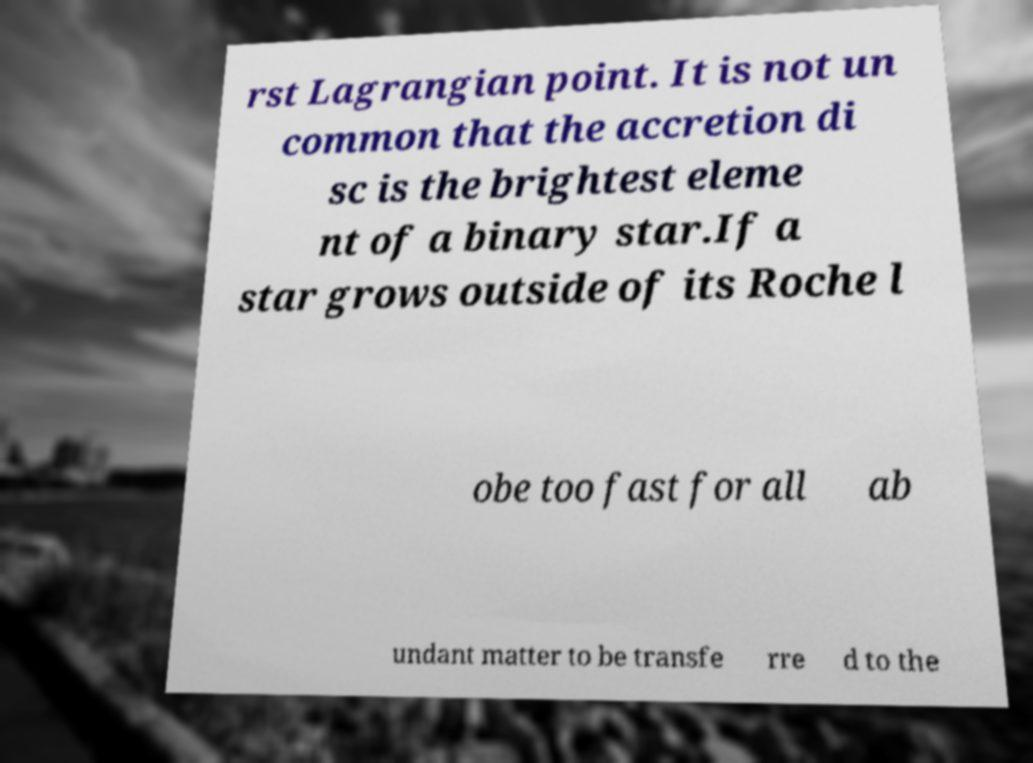Can you read and provide the text displayed in the image?This photo seems to have some interesting text. Can you extract and type it out for me? rst Lagrangian point. It is not un common that the accretion di sc is the brightest eleme nt of a binary star.If a star grows outside of its Roche l obe too fast for all ab undant matter to be transfe rre d to the 